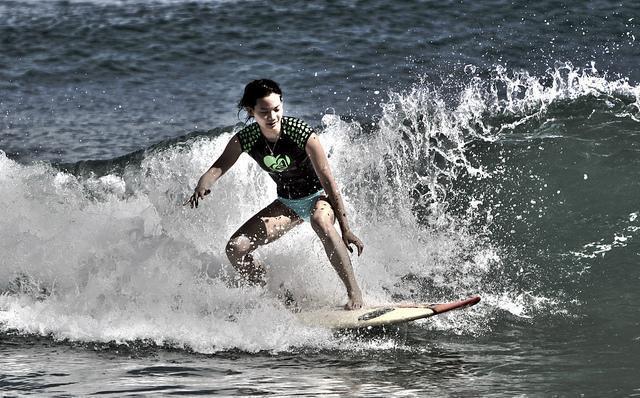How many feet does the surfer have?
Give a very brief answer. 2. 